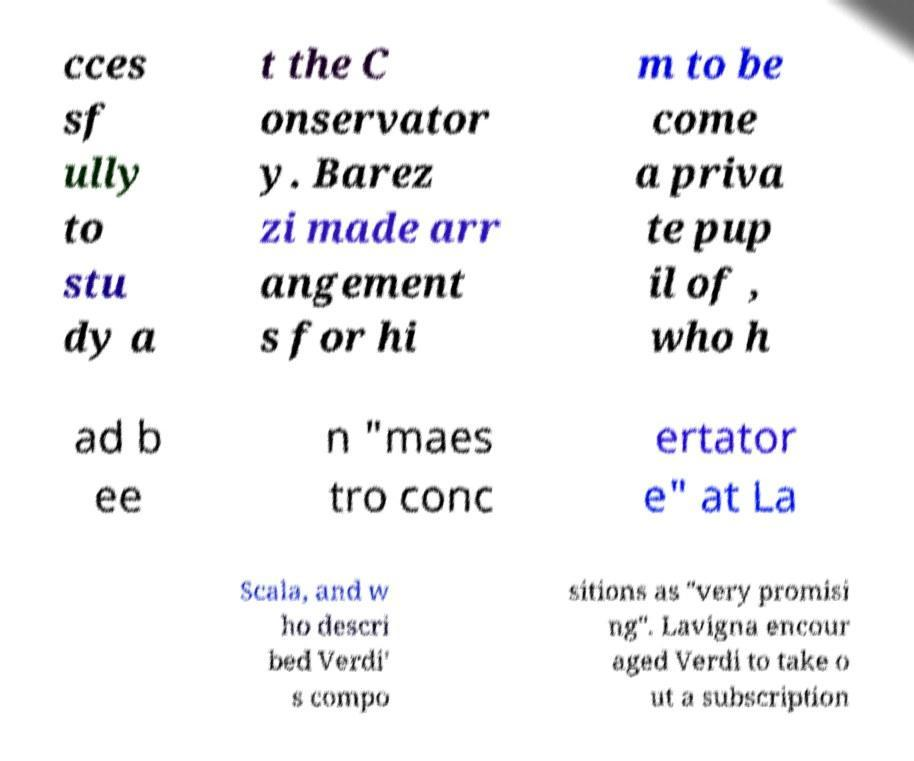I need the written content from this picture converted into text. Can you do that? cces sf ully to stu dy a t the C onservator y. Barez zi made arr angement s for hi m to be come a priva te pup il of , who h ad b ee n "maes tro conc ertator e" at La Scala, and w ho descri bed Verdi' s compo sitions as "very promisi ng". Lavigna encour aged Verdi to take o ut a subscription 